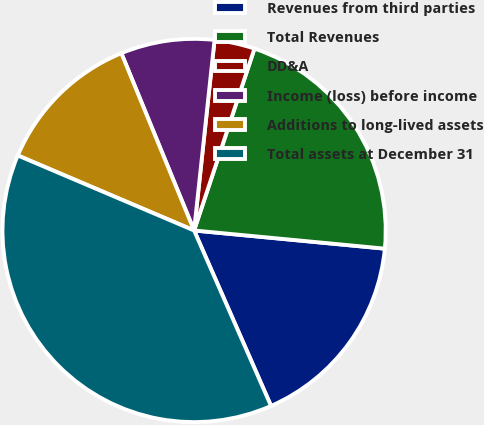<chart> <loc_0><loc_0><loc_500><loc_500><pie_chart><fcel>Revenues from third parties<fcel>Total Revenues<fcel>DD&A<fcel>Income (loss) before income<fcel>Additions to long-lived assets<fcel>Total assets at December 31<nl><fcel>16.91%<fcel>21.41%<fcel>3.4%<fcel>7.9%<fcel>12.4%<fcel>37.98%<nl></chart> 